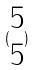<formula> <loc_0><loc_0><loc_500><loc_500>( \begin{matrix} 5 \\ 5 \end{matrix} )</formula> 